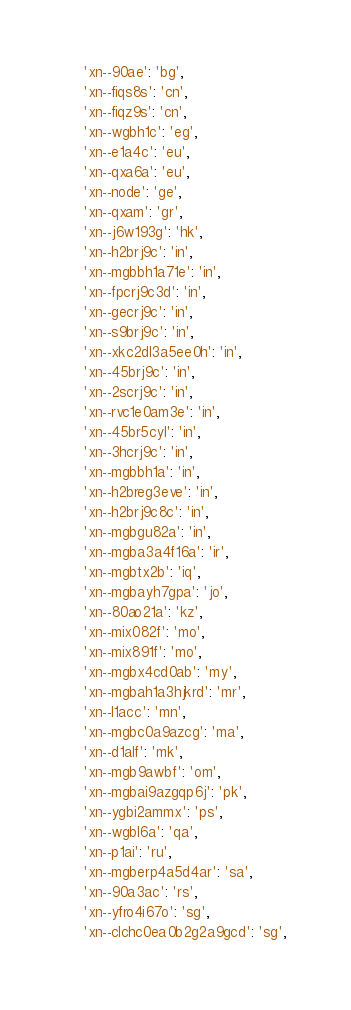<code> <loc_0><loc_0><loc_500><loc_500><_Python_>    'xn--90ae': 'bg',
    'xn--fiqs8s': 'cn',
    'xn--fiqz9s': 'cn',
    'xn--wgbh1c': 'eg',
    'xn--e1a4c': 'eu',
    'xn--qxa6a': 'eu',
    'xn--node': 'ge',
    'xn--qxam': 'gr',
    'xn--j6w193g': 'hk',
    'xn--h2brj9c': 'in',
    'xn--mgbbh1a71e': 'in',
    'xn--fpcrj9c3d': 'in',
    'xn--gecrj9c': 'in',
    'xn--s9brj9c': 'in',
    'xn--xkc2dl3a5ee0h': 'in',
    'xn--45brj9c': 'in',
    'xn--2scrj9c': 'in',
    'xn--rvc1e0am3e': 'in',
    'xn--45br5cyl': 'in',
    'xn--3hcrj9c': 'in',
    'xn--mgbbh1a': 'in',
    'xn--h2breg3eve': 'in',
    'xn--h2brj9c8c': 'in',
    'xn--mgbgu82a': 'in',
    'xn--mgba3a4f16a': 'ir',
    'xn--mgbtx2b': 'iq',
    'xn--mgbayh7gpa': 'jo',
    'xn--80ao21a': 'kz',
    'xn--mix082f': 'mo',
    'xn--mix891f': 'mo',
    'xn--mgbx4cd0ab': 'my',
    'xn--mgbah1a3hjkrd': 'mr',
    'xn--l1acc': 'mn',
    'xn--mgbc0a9azcg': 'ma',
    'xn--d1alf': 'mk',
    'xn--mgb9awbf': 'om',
    'xn--mgbai9azgqp6j': 'pk',
    'xn--ygbi2ammx': 'ps',
    'xn--wgbl6a': 'qa',
    'xn--p1ai': 'ru',
    'xn--mgberp4a5d4ar': 'sa',
    'xn--90a3ac': 'rs',
    'xn--yfro4i67o': 'sg',
    'xn--clchc0ea0b2g2a9gcd': 'sg',</code> 